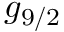Convert formula to latex. <formula><loc_0><loc_0><loc_500><loc_500>g _ { 9 / 2 }</formula> 